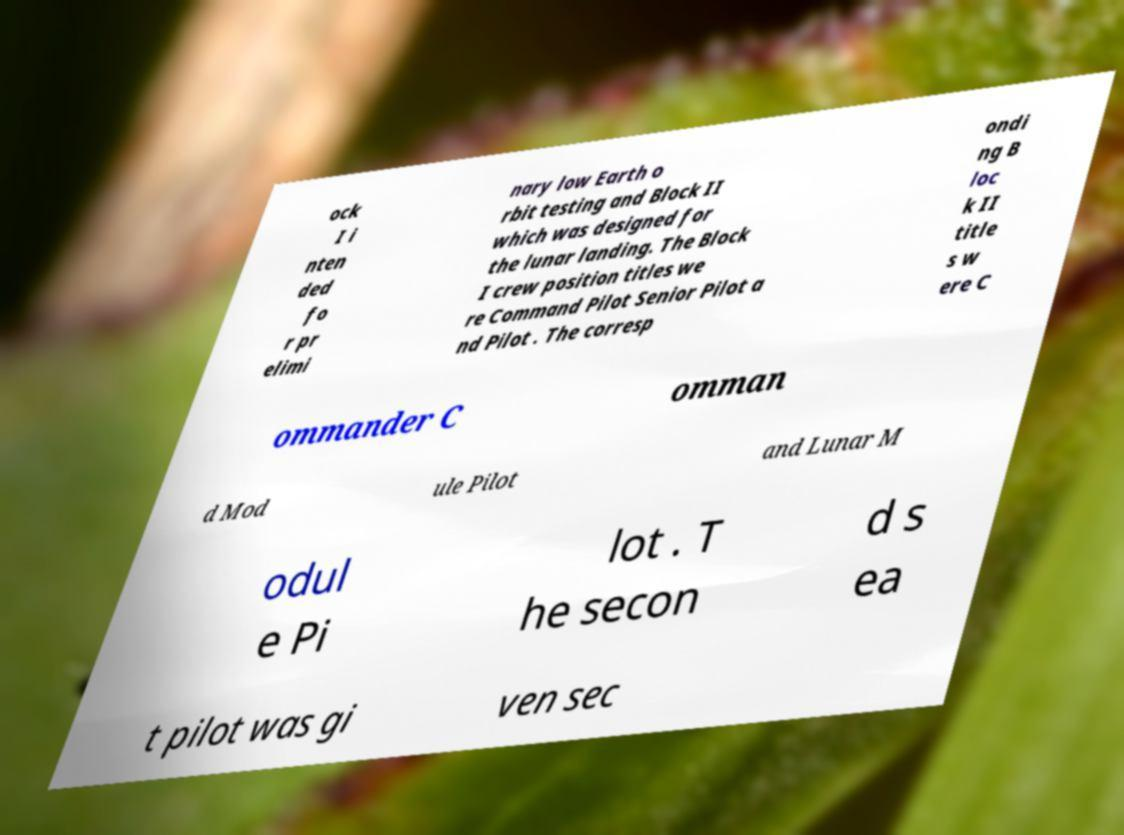Please read and relay the text visible in this image. What does it say? ock I i nten ded fo r pr elimi nary low Earth o rbit testing and Block II which was designed for the lunar landing. The Block I crew position titles we re Command Pilot Senior Pilot a nd Pilot . The corresp ondi ng B loc k II title s w ere C ommander C omman d Mod ule Pilot and Lunar M odul e Pi lot . T he secon d s ea t pilot was gi ven sec 